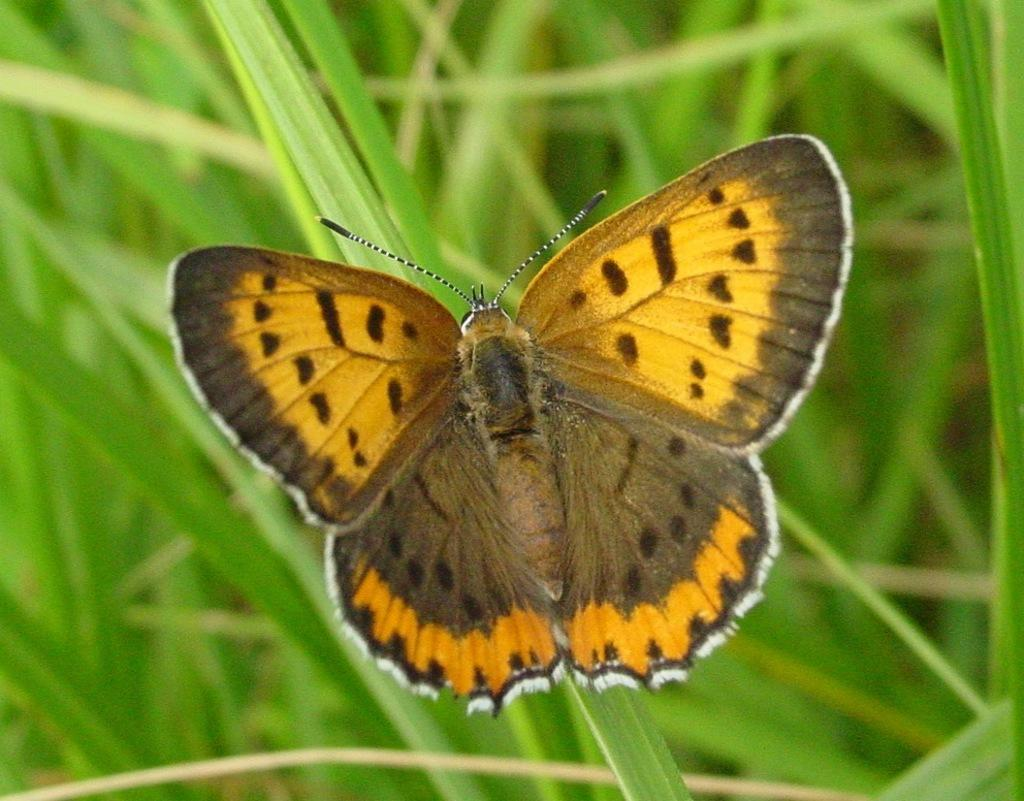What is the main subject of the image? There is a butterfly in the image. Where is the butterfly located? The butterfly is on grass. What grade is the butterfly in the image? Butterflies do not attend school or have grades; they are insects. Is there a squirrel visible in the image? No, there is no squirrel mentioned or visible in the image. 